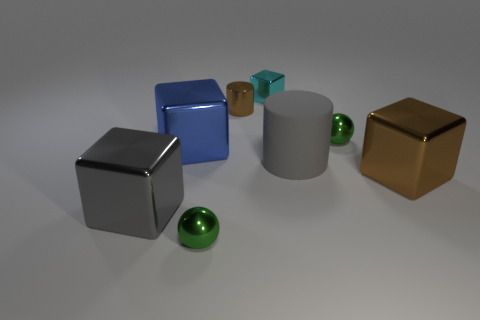Add 2 tiny things. How many objects exist? 10 Subtract all large metallic cubes. How many cubes are left? 1 Subtract all blue cubes. How many cubes are left? 3 Subtract all balls. How many objects are left? 6 Subtract 4 blocks. How many blocks are left? 0 Add 8 tiny blue things. How many tiny blue things exist? 8 Subtract 2 green balls. How many objects are left? 6 Subtract all blue cylinders. Subtract all gray blocks. How many cylinders are left? 2 Subtract all purple cubes. How many blue balls are left? 0 Subtract all big rubber cylinders. Subtract all gray cylinders. How many objects are left? 6 